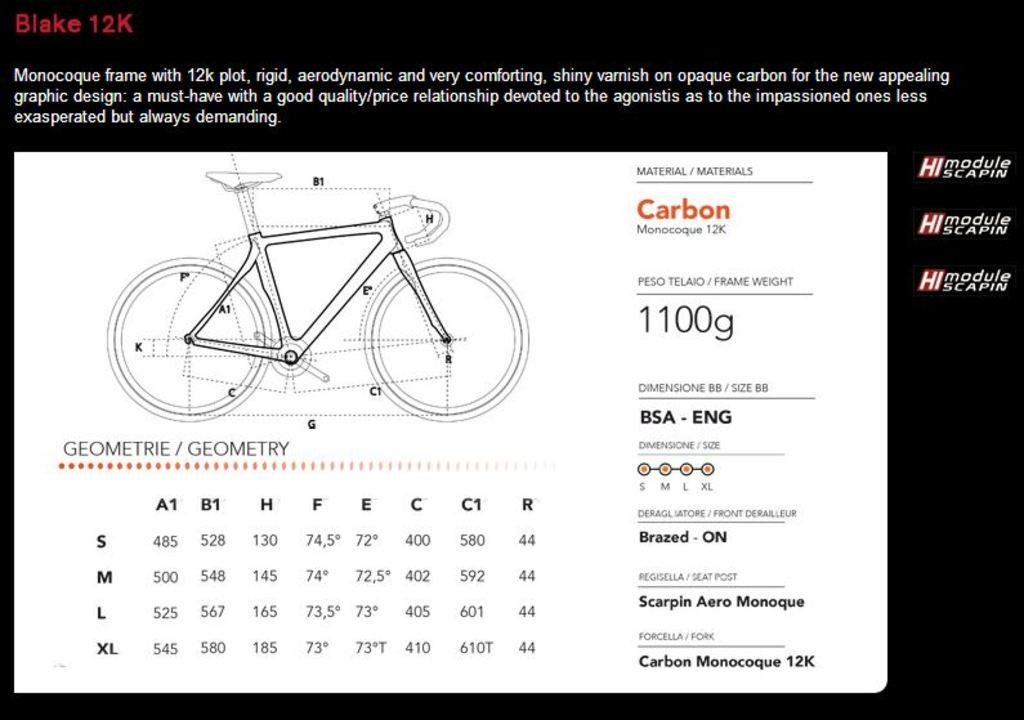What is the main subject of the picture? The main subject of the picture is a bicycle. Are there any words or letters on the bicycle? Yes, there is text written on the bicycle. What type of notebook is the bicycle holding in the picture? There is no notebook present in the picture; it only features a bicycle with text written on it. 